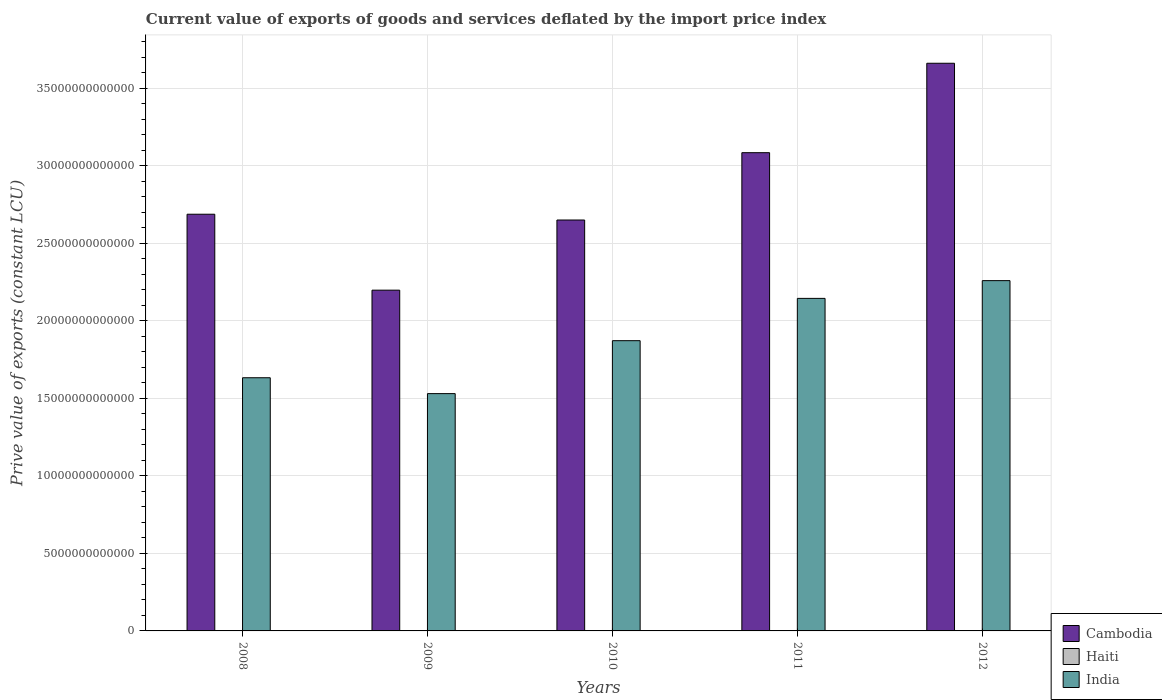How many different coloured bars are there?
Give a very brief answer. 3. How many groups of bars are there?
Make the answer very short. 5. What is the label of the 3rd group of bars from the left?
Give a very brief answer. 2010. In how many cases, is the number of bars for a given year not equal to the number of legend labels?
Your answer should be very brief. 0. What is the prive value of exports in Haiti in 2010?
Provide a short and direct response. 5.24e+09. Across all years, what is the maximum prive value of exports in India?
Offer a very short reply. 2.26e+13. Across all years, what is the minimum prive value of exports in India?
Your answer should be very brief. 1.53e+13. In which year was the prive value of exports in Cambodia maximum?
Your answer should be compact. 2012. In which year was the prive value of exports in Haiti minimum?
Your response must be concise. 2008. What is the total prive value of exports in Cambodia in the graph?
Make the answer very short. 1.43e+14. What is the difference between the prive value of exports in Cambodia in 2009 and that in 2010?
Keep it short and to the point. -4.52e+12. What is the difference between the prive value of exports in Cambodia in 2009 and the prive value of exports in India in 2012?
Provide a short and direct response. -6.14e+11. What is the average prive value of exports in Cambodia per year?
Offer a terse response. 2.86e+13. In the year 2011, what is the difference between the prive value of exports in Haiti and prive value of exports in India?
Provide a succinct answer. -2.14e+13. What is the ratio of the prive value of exports in India in 2008 to that in 2011?
Offer a very short reply. 0.76. What is the difference between the highest and the second highest prive value of exports in India?
Make the answer very short. 1.14e+12. What is the difference between the highest and the lowest prive value of exports in India?
Your response must be concise. 7.28e+12. In how many years, is the prive value of exports in India greater than the average prive value of exports in India taken over all years?
Keep it short and to the point. 2. What does the 1st bar from the left in 2008 represents?
Ensure brevity in your answer.  Cambodia. Is it the case that in every year, the sum of the prive value of exports in India and prive value of exports in Cambodia is greater than the prive value of exports in Haiti?
Ensure brevity in your answer.  Yes. How many bars are there?
Give a very brief answer. 15. Are all the bars in the graph horizontal?
Your answer should be very brief. No. What is the difference between two consecutive major ticks on the Y-axis?
Your answer should be compact. 5.00e+12. Does the graph contain any zero values?
Keep it short and to the point. No. Does the graph contain grids?
Offer a terse response. Yes. Where does the legend appear in the graph?
Keep it short and to the point. Bottom right. How many legend labels are there?
Ensure brevity in your answer.  3. What is the title of the graph?
Offer a terse response. Current value of exports of goods and services deflated by the import price index. What is the label or title of the Y-axis?
Provide a short and direct response. Prive value of exports (constant LCU). What is the Prive value of exports (constant LCU) of Cambodia in 2008?
Give a very brief answer. 2.69e+13. What is the Prive value of exports (constant LCU) of Haiti in 2008?
Ensure brevity in your answer.  4.99e+09. What is the Prive value of exports (constant LCU) in India in 2008?
Keep it short and to the point. 1.63e+13. What is the Prive value of exports (constant LCU) in Cambodia in 2009?
Provide a short and direct response. 2.20e+13. What is the Prive value of exports (constant LCU) in Haiti in 2009?
Provide a succinct answer. 6.76e+09. What is the Prive value of exports (constant LCU) in India in 2009?
Ensure brevity in your answer.  1.53e+13. What is the Prive value of exports (constant LCU) of Cambodia in 2010?
Your answer should be compact. 2.65e+13. What is the Prive value of exports (constant LCU) of Haiti in 2010?
Your answer should be very brief. 5.24e+09. What is the Prive value of exports (constant LCU) of India in 2010?
Your answer should be very brief. 1.87e+13. What is the Prive value of exports (constant LCU) in Cambodia in 2011?
Give a very brief answer. 3.08e+13. What is the Prive value of exports (constant LCU) of Haiti in 2011?
Your answer should be very brief. 6.55e+09. What is the Prive value of exports (constant LCU) in India in 2011?
Your answer should be very brief. 2.14e+13. What is the Prive value of exports (constant LCU) in Cambodia in 2012?
Offer a terse response. 3.66e+13. What is the Prive value of exports (constant LCU) in Haiti in 2012?
Provide a short and direct response. 6.64e+09. What is the Prive value of exports (constant LCU) of India in 2012?
Your answer should be very brief. 2.26e+13. Across all years, what is the maximum Prive value of exports (constant LCU) in Cambodia?
Provide a succinct answer. 3.66e+13. Across all years, what is the maximum Prive value of exports (constant LCU) of Haiti?
Offer a terse response. 6.76e+09. Across all years, what is the maximum Prive value of exports (constant LCU) in India?
Provide a succinct answer. 2.26e+13. Across all years, what is the minimum Prive value of exports (constant LCU) of Cambodia?
Provide a succinct answer. 2.20e+13. Across all years, what is the minimum Prive value of exports (constant LCU) in Haiti?
Offer a terse response. 4.99e+09. Across all years, what is the minimum Prive value of exports (constant LCU) in India?
Your answer should be compact. 1.53e+13. What is the total Prive value of exports (constant LCU) in Cambodia in the graph?
Provide a succinct answer. 1.43e+14. What is the total Prive value of exports (constant LCU) in Haiti in the graph?
Your answer should be compact. 3.02e+1. What is the total Prive value of exports (constant LCU) in India in the graph?
Your response must be concise. 9.44e+13. What is the difference between the Prive value of exports (constant LCU) of Cambodia in 2008 and that in 2009?
Give a very brief answer. 4.90e+12. What is the difference between the Prive value of exports (constant LCU) of Haiti in 2008 and that in 2009?
Offer a very short reply. -1.77e+09. What is the difference between the Prive value of exports (constant LCU) in India in 2008 and that in 2009?
Provide a short and direct response. 1.02e+12. What is the difference between the Prive value of exports (constant LCU) of Cambodia in 2008 and that in 2010?
Make the answer very short. 3.73e+11. What is the difference between the Prive value of exports (constant LCU) in Haiti in 2008 and that in 2010?
Provide a succinct answer. -2.55e+08. What is the difference between the Prive value of exports (constant LCU) of India in 2008 and that in 2010?
Provide a succinct answer. -2.39e+12. What is the difference between the Prive value of exports (constant LCU) in Cambodia in 2008 and that in 2011?
Provide a succinct answer. -3.97e+12. What is the difference between the Prive value of exports (constant LCU) in Haiti in 2008 and that in 2011?
Keep it short and to the point. -1.57e+09. What is the difference between the Prive value of exports (constant LCU) in India in 2008 and that in 2011?
Your answer should be very brief. -5.12e+12. What is the difference between the Prive value of exports (constant LCU) of Cambodia in 2008 and that in 2012?
Ensure brevity in your answer.  -9.73e+12. What is the difference between the Prive value of exports (constant LCU) of Haiti in 2008 and that in 2012?
Your response must be concise. -1.66e+09. What is the difference between the Prive value of exports (constant LCU) of India in 2008 and that in 2012?
Offer a terse response. -6.26e+12. What is the difference between the Prive value of exports (constant LCU) in Cambodia in 2009 and that in 2010?
Ensure brevity in your answer.  -4.52e+12. What is the difference between the Prive value of exports (constant LCU) of Haiti in 2009 and that in 2010?
Provide a short and direct response. 1.52e+09. What is the difference between the Prive value of exports (constant LCU) of India in 2009 and that in 2010?
Keep it short and to the point. -3.41e+12. What is the difference between the Prive value of exports (constant LCU) in Cambodia in 2009 and that in 2011?
Give a very brief answer. -8.86e+12. What is the difference between the Prive value of exports (constant LCU) of Haiti in 2009 and that in 2011?
Ensure brevity in your answer.  2.08e+08. What is the difference between the Prive value of exports (constant LCU) in India in 2009 and that in 2011?
Offer a very short reply. -6.14e+12. What is the difference between the Prive value of exports (constant LCU) of Cambodia in 2009 and that in 2012?
Ensure brevity in your answer.  -1.46e+13. What is the difference between the Prive value of exports (constant LCU) in Haiti in 2009 and that in 2012?
Provide a short and direct response. 1.18e+08. What is the difference between the Prive value of exports (constant LCU) of India in 2009 and that in 2012?
Give a very brief answer. -7.28e+12. What is the difference between the Prive value of exports (constant LCU) of Cambodia in 2010 and that in 2011?
Offer a terse response. -4.34e+12. What is the difference between the Prive value of exports (constant LCU) in Haiti in 2010 and that in 2011?
Offer a very short reply. -1.31e+09. What is the difference between the Prive value of exports (constant LCU) in India in 2010 and that in 2011?
Your answer should be compact. -2.73e+12. What is the difference between the Prive value of exports (constant LCU) in Cambodia in 2010 and that in 2012?
Your answer should be very brief. -1.01e+13. What is the difference between the Prive value of exports (constant LCU) in Haiti in 2010 and that in 2012?
Keep it short and to the point. -1.40e+09. What is the difference between the Prive value of exports (constant LCU) in India in 2010 and that in 2012?
Offer a very short reply. -3.87e+12. What is the difference between the Prive value of exports (constant LCU) in Cambodia in 2011 and that in 2012?
Provide a succinct answer. -5.77e+12. What is the difference between the Prive value of exports (constant LCU) of Haiti in 2011 and that in 2012?
Offer a terse response. -9.05e+07. What is the difference between the Prive value of exports (constant LCU) of India in 2011 and that in 2012?
Give a very brief answer. -1.14e+12. What is the difference between the Prive value of exports (constant LCU) of Cambodia in 2008 and the Prive value of exports (constant LCU) of Haiti in 2009?
Offer a very short reply. 2.69e+13. What is the difference between the Prive value of exports (constant LCU) of Cambodia in 2008 and the Prive value of exports (constant LCU) of India in 2009?
Make the answer very short. 1.16e+13. What is the difference between the Prive value of exports (constant LCU) of Haiti in 2008 and the Prive value of exports (constant LCU) of India in 2009?
Offer a very short reply. -1.53e+13. What is the difference between the Prive value of exports (constant LCU) in Cambodia in 2008 and the Prive value of exports (constant LCU) in Haiti in 2010?
Keep it short and to the point. 2.69e+13. What is the difference between the Prive value of exports (constant LCU) of Cambodia in 2008 and the Prive value of exports (constant LCU) of India in 2010?
Give a very brief answer. 8.15e+12. What is the difference between the Prive value of exports (constant LCU) of Haiti in 2008 and the Prive value of exports (constant LCU) of India in 2010?
Keep it short and to the point. -1.87e+13. What is the difference between the Prive value of exports (constant LCU) of Cambodia in 2008 and the Prive value of exports (constant LCU) of Haiti in 2011?
Keep it short and to the point. 2.69e+13. What is the difference between the Prive value of exports (constant LCU) in Cambodia in 2008 and the Prive value of exports (constant LCU) in India in 2011?
Offer a very short reply. 5.43e+12. What is the difference between the Prive value of exports (constant LCU) of Haiti in 2008 and the Prive value of exports (constant LCU) of India in 2011?
Your answer should be very brief. -2.14e+13. What is the difference between the Prive value of exports (constant LCU) of Cambodia in 2008 and the Prive value of exports (constant LCU) of Haiti in 2012?
Offer a terse response. 2.69e+13. What is the difference between the Prive value of exports (constant LCU) of Cambodia in 2008 and the Prive value of exports (constant LCU) of India in 2012?
Your answer should be compact. 4.28e+12. What is the difference between the Prive value of exports (constant LCU) of Haiti in 2008 and the Prive value of exports (constant LCU) of India in 2012?
Your answer should be very brief. -2.26e+13. What is the difference between the Prive value of exports (constant LCU) in Cambodia in 2009 and the Prive value of exports (constant LCU) in Haiti in 2010?
Give a very brief answer. 2.20e+13. What is the difference between the Prive value of exports (constant LCU) of Cambodia in 2009 and the Prive value of exports (constant LCU) of India in 2010?
Provide a short and direct response. 3.26e+12. What is the difference between the Prive value of exports (constant LCU) in Haiti in 2009 and the Prive value of exports (constant LCU) in India in 2010?
Your answer should be compact. -1.87e+13. What is the difference between the Prive value of exports (constant LCU) of Cambodia in 2009 and the Prive value of exports (constant LCU) of Haiti in 2011?
Offer a terse response. 2.20e+13. What is the difference between the Prive value of exports (constant LCU) in Cambodia in 2009 and the Prive value of exports (constant LCU) in India in 2011?
Your answer should be compact. 5.29e+11. What is the difference between the Prive value of exports (constant LCU) of Haiti in 2009 and the Prive value of exports (constant LCU) of India in 2011?
Ensure brevity in your answer.  -2.14e+13. What is the difference between the Prive value of exports (constant LCU) in Cambodia in 2009 and the Prive value of exports (constant LCU) in Haiti in 2012?
Give a very brief answer. 2.20e+13. What is the difference between the Prive value of exports (constant LCU) in Cambodia in 2009 and the Prive value of exports (constant LCU) in India in 2012?
Make the answer very short. -6.14e+11. What is the difference between the Prive value of exports (constant LCU) of Haiti in 2009 and the Prive value of exports (constant LCU) of India in 2012?
Offer a terse response. -2.26e+13. What is the difference between the Prive value of exports (constant LCU) of Cambodia in 2010 and the Prive value of exports (constant LCU) of Haiti in 2011?
Your answer should be very brief. 2.65e+13. What is the difference between the Prive value of exports (constant LCU) in Cambodia in 2010 and the Prive value of exports (constant LCU) in India in 2011?
Offer a terse response. 5.05e+12. What is the difference between the Prive value of exports (constant LCU) in Haiti in 2010 and the Prive value of exports (constant LCU) in India in 2011?
Keep it short and to the point. -2.14e+13. What is the difference between the Prive value of exports (constant LCU) in Cambodia in 2010 and the Prive value of exports (constant LCU) in Haiti in 2012?
Make the answer very short. 2.65e+13. What is the difference between the Prive value of exports (constant LCU) of Cambodia in 2010 and the Prive value of exports (constant LCU) of India in 2012?
Offer a very short reply. 3.91e+12. What is the difference between the Prive value of exports (constant LCU) of Haiti in 2010 and the Prive value of exports (constant LCU) of India in 2012?
Ensure brevity in your answer.  -2.26e+13. What is the difference between the Prive value of exports (constant LCU) of Cambodia in 2011 and the Prive value of exports (constant LCU) of Haiti in 2012?
Ensure brevity in your answer.  3.08e+13. What is the difference between the Prive value of exports (constant LCU) in Cambodia in 2011 and the Prive value of exports (constant LCU) in India in 2012?
Your response must be concise. 8.25e+12. What is the difference between the Prive value of exports (constant LCU) in Haiti in 2011 and the Prive value of exports (constant LCU) in India in 2012?
Provide a short and direct response. -2.26e+13. What is the average Prive value of exports (constant LCU) in Cambodia per year?
Offer a very short reply. 2.86e+13. What is the average Prive value of exports (constant LCU) of Haiti per year?
Offer a terse response. 6.04e+09. What is the average Prive value of exports (constant LCU) of India per year?
Give a very brief answer. 1.89e+13. In the year 2008, what is the difference between the Prive value of exports (constant LCU) of Cambodia and Prive value of exports (constant LCU) of Haiti?
Your answer should be compact. 2.69e+13. In the year 2008, what is the difference between the Prive value of exports (constant LCU) in Cambodia and Prive value of exports (constant LCU) in India?
Offer a terse response. 1.05e+13. In the year 2008, what is the difference between the Prive value of exports (constant LCU) of Haiti and Prive value of exports (constant LCU) of India?
Provide a short and direct response. -1.63e+13. In the year 2009, what is the difference between the Prive value of exports (constant LCU) of Cambodia and Prive value of exports (constant LCU) of Haiti?
Your response must be concise. 2.20e+13. In the year 2009, what is the difference between the Prive value of exports (constant LCU) of Cambodia and Prive value of exports (constant LCU) of India?
Ensure brevity in your answer.  6.67e+12. In the year 2009, what is the difference between the Prive value of exports (constant LCU) in Haiti and Prive value of exports (constant LCU) in India?
Give a very brief answer. -1.53e+13. In the year 2010, what is the difference between the Prive value of exports (constant LCU) of Cambodia and Prive value of exports (constant LCU) of Haiti?
Keep it short and to the point. 2.65e+13. In the year 2010, what is the difference between the Prive value of exports (constant LCU) in Cambodia and Prive value of exports (constant LCU) in India?
Offer a terse response. 7.78e+12. In the year 2010, what is the difference between the Prive value of exports (constant LCU) in Haiti and Prive value of exports (constant LCU) in India?
Your answer should be compact. -1.87e+13. In the year 2011, what is the difference between the Prive value of exports (constant LCU) in Cambodia and Prive value of exports (constant LCU) in Haiti?
Ensure brevity in your answer.  3.08e+13. In the year 2011, what is the difference between the Prive value of exports (constant LCU) in Cambodia and Prive value of exports (constant LCU) in India?
Ensure brevity in your answer.  9.39e+12. In the year 2011, what is the difference between the Prive value of exports (constant LCU) of Haiti and Prive value of exports (constant LCU) of India?
Provide a succinct answer. -2.14e+13. In the year 2012, what is the difference between the Prive value of exports (constant LCU) of Cambodia and Prive value of exports (constant LCU) of Haiti?
Ensure brevity in your answer.  3.66e+13. In the year 2012, what is the difference between the Prive value of exports (constant LCU) of Cambodia and Prive value of exports (constant LCU) of India?
Offer a very short reply. 1.40e+13. In the year 2012, what is the difference between the Prive value of exports (constant LCU) in Haiti and Prive value of exports (constant LCU) in India?
Your answer should be compact. -2.26e+13. What is the ratio of the Prive value of exports (constant LCU) of Cambodia in 2008 to that in 2009?
Provide a succinct answer. 1.22. What is the ratio of the Prive value of exports (constant LCU) in Haiti in 2008 to that in 2009?
Offer a very short reply. 0.74. What is the ratio of the Prive value of exports (constant LCU) in India in 2008 to that in 2009?
Offer a terse response. 1.07. What is the ratio of the Prive value of exports (constant LCU) in Cambodia in 2008 to that in 2010?
Ensure brevity in your answer.  1.01. What is the ratio of the Prive value of exports (constant LCU) of Haiti in 2008 to that in 2010?
Offer a terse response. 0.95. What is the ratio of the Prive value of exports (constant LCU) of India in 2008 to that in 2010?
Ensure brevity in your answer.  0.87. What is the ratio of the Prive value of exports (constant LCU) of Cambodia in 2008 to that in 2011?
Your answer should be compact. 0.87. What is the ratio of the Prive value of exports (constant LCU) of Haiti in 2008 to that in 2011?
Your answer should be very brief. 0.76. What is the ratio of the Prive value of exports (constant LCU) in India in 2008 to that in 2011?
Your answer should be compact. 0.76. What is the ratio of the Prive value of exports (constant LCU) in Cambodia in 2008 to that in 2012?
Your answer should be very brief. 0.73. What is the ratio of the Prive value of exports (constant LCU) of Haiti in 2008 to that in 2012?
Provide a short and direct response. 0.75. What is the ratio of the Prive value of exports (constant LCU) of India in 2008 to that in 2012?
Give a very brief answer. 0.72. What is the ratio of the Prive value of exports (constant LCU) of Cambodia in 2009 to that in 2010?
Give a very brief answer. 0.83. What is the ratio of the Prive value of exports (constant LCU) of Haiti in 2009 to that in 2010?
Provide a succinct answer. 1.29. What is the ratio of the Prive value of exports (constant LCU) of India in 2009 to that in 2010?
Your response must be concise. 0.82. What is the ratio of the Prive value of exports (constant LCU) of Cambodia in 2009 to that in 2011?
Give a very brief answer. 0.71. What is the ratio of the Prive value of exports (constant LCU) in Haiti in 2009 to that in 2011?
Your answer should be very brief. 1.03. What is the ratio of the Prive value of exports (constant LCU) in India in 2009 to that in 2011?
Your answer should be compact. 0.71. What is the ratio of the Prive value of exports (constant LCU) in Cambodia in 2009 to that in 2012?
Offer a very short reply. 0.6. What is the ratio of the Prive value of exports (constant LCU) of Haiti in 2009 to that in 2012?
Offer a terse response. 1.02. What is the ratio of the Prive value of exports (constant LCU) of India in 2009 to that in 2012?
Provide a succinct answer. 0.68. What is the ratio of the Prive value of exports (constant LCU) of Cambodia in 2010 to that in 2011?
Keep it short and to the point. 0.86. What is the ratio of the Prive value of exports (constant LCU) of Haiti in 2010 to that in 2011?
Offer a very short reply. 0.8. What is the ratio of the Prive value of exports (constant LCU) in India in 2010 to that in 2011?
Ensure brevity in your answer.  0.87. What is the ratio of the Prive value of exports (constant LCU) in Cambodia in 2010 to that in 2012?
Keep it short and to the point. 0.72. What is the ratio of the Prive value of exports (constant LCU) in Haiti in 2010 to that in 2012?
Keep it short and to the point. 0.79. What is the ratio of the Prive value of exports (constant LCU) in India in 2010 to that in 2012?
Provide a succinct answer. 0.83. What is the ratio of the Prive value of exports (constant LCU) in Cambodia in 2011 to that in 2012?
Provide a succinct answer. 0.84. What is the ratio of the Prive value of exports (constant LCU) of Haiti in 2011 to that in 2012?
Offer a very short reply. 0.99. What is the ratio of the Prive value of exports (constant LCU) in India in 2011 to that in 2012?
Give a very brief answer. 0.95. What is the difference between the highest and the second highest Prive value of exports (constant LCU) of Cambodia?
Make the answer very short. 5.77e+12. What is the difference between the highest and the second highest Prive value of exports (constant LCU) of Haiti?
Keep it short and to the point. 1.18e+08. What is the difference between the highest and the second highest Prive value of exports (constant LCU) in India?
Give a very brief answer. 1.14e+12. What is the difference between the highest and the lowest Prive value of exports (constant LCU) of Cambodia?
Offer a very short reply. 1.46e+13. What is the difference between the highest and the lowest Prive value of exports (constant LCU) of Haiti?
Give a very brief answer. 1.77e+09. What is the difference between the highest and the lowest Prive value of exports (constant LCU) in India?
Provide a succinct answer. 7.28e+12. 